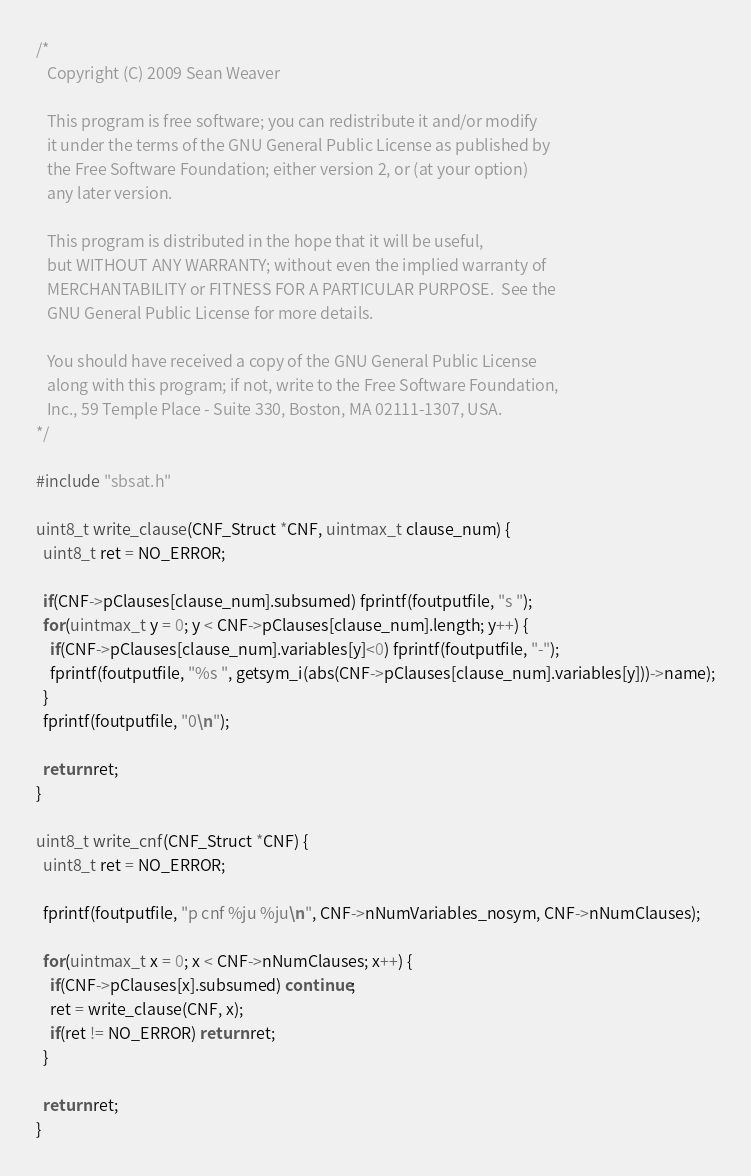Convert code to text. <code><loc_0><loc_0><loc_500><loc_500><_C_>/*
   Copyright (C) 2009 Sean Weaver

   This program is free software; you can redistribute it and/or modify
   it under the terms of the GNU General Public License as published by
   the Free Software Foundation; either version 2, or (at your option)
   any later version.

   This program is distributed in the hope that it will be useful,
   but WITHOUT ANY WARRANTY; without even the implied warranty of
   MERCHANTABILITY or FITNESS FOR A PARTICULAR PURPOSE.  See the
   GNU General Public License for more details.

   You should have received a copy of the GNU General Public License
   along with this program; if not, write to the Free Software Foundation,
   Inc., 59 Temple Place - Suite 330, Boston, MA 02111-1307, USA.
*/

#include "sbsat.h"

uint8_t write_clause(CNF_Struct *CNF, uintmax_t clause_num) {
  uint8_t ret = NO_ERROR;
  
  if(CNF->pClauses[clause_num].subsumed) fprintf(foutputfile, "s ");
  for(uintmax_t y = 0; y < CNF->pClauses[clause_num].length; y++) {
    if(CNF->pClauses[clause_num].variables[y]<0) fprintf(foutputfile, "-");
    fprintf(foutputfile, "%s ", getsym_i(abs(CNF->pClauses[clause_num].variables[y]))->name);
  }
  fprintf(foutputfile, "0\n");
  
  return ret;
}

uint8_t write_cnf(CNF_Struct *CNF) {
  uint8_t ret = NO_ERROR;
  
  fprintf(foutputfile, "p cnf %ju %ju\n", CNF->nNumVariables_nosym, CNF->nNumClauses);
  
  for(uintmax_t x = 0; x < CNF->nNumClauses; x++) {
    if(CNF->pClauses[x].subsumed) continue;
    ret = write_clause(CNF, x);
    if(ret != NO_ERROR) return ret;
  }
  
  return ret;
}
</code> 